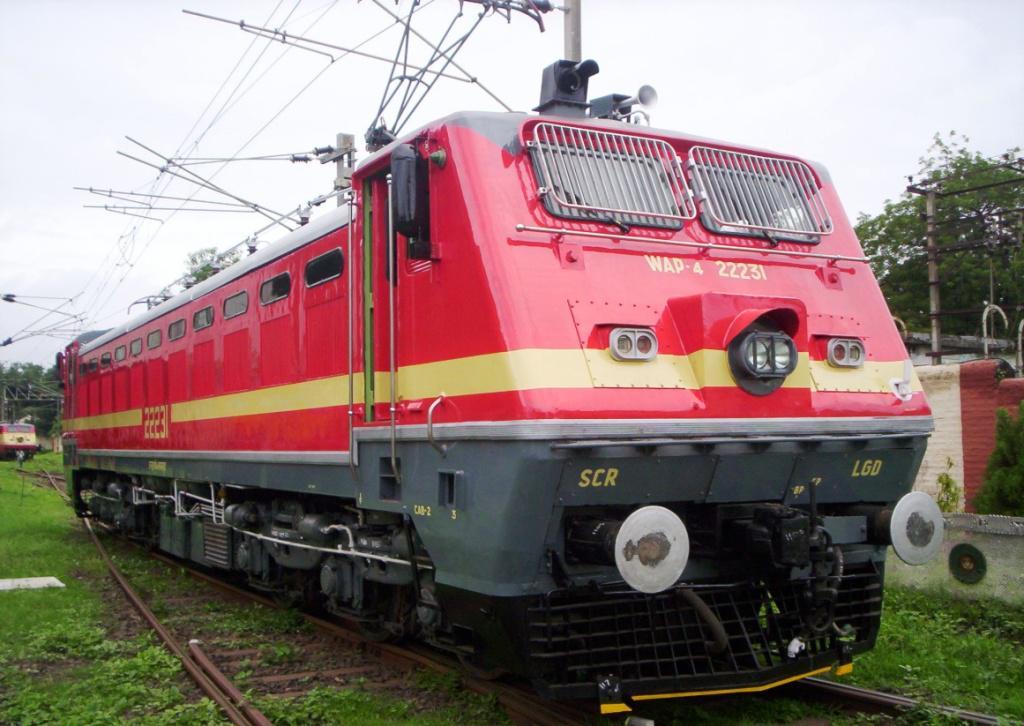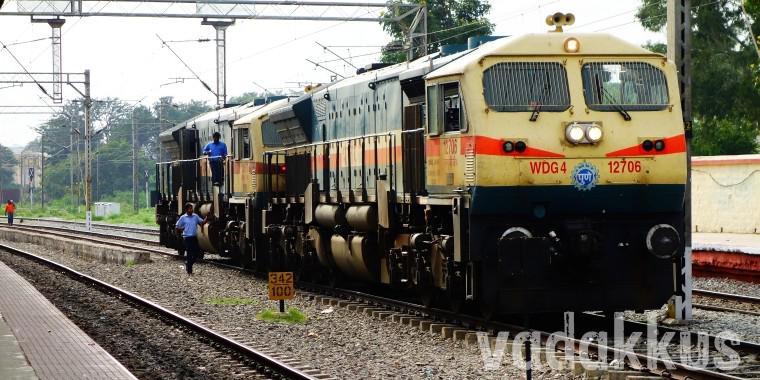The first image is the image on the left, the second image is the image on the right. Examine the images to the left and right. Is the description "There are two trains in the image on the right." accurate? Answer yes or no. No. 